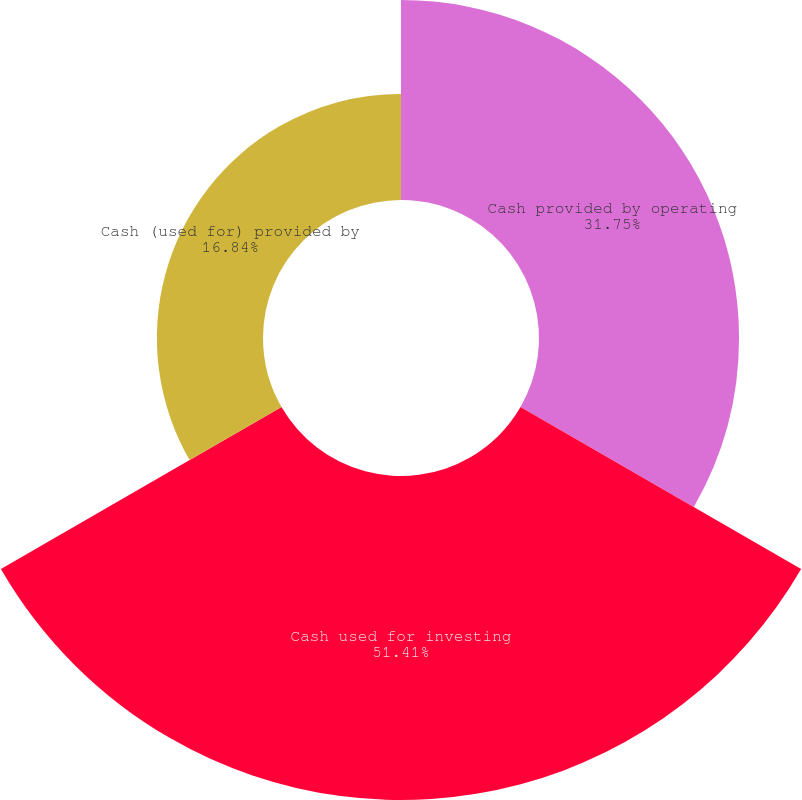<chart> <loc_0><loc_0><loc_500><loc_500><pie_chart><fcel>Cash provided by operating<fcel>Cash used for investing<fcel>Cash (used for) provided by<nl><fcel>31.75%<fcel>51.42%<fcel>16.84%<nl></chart> 